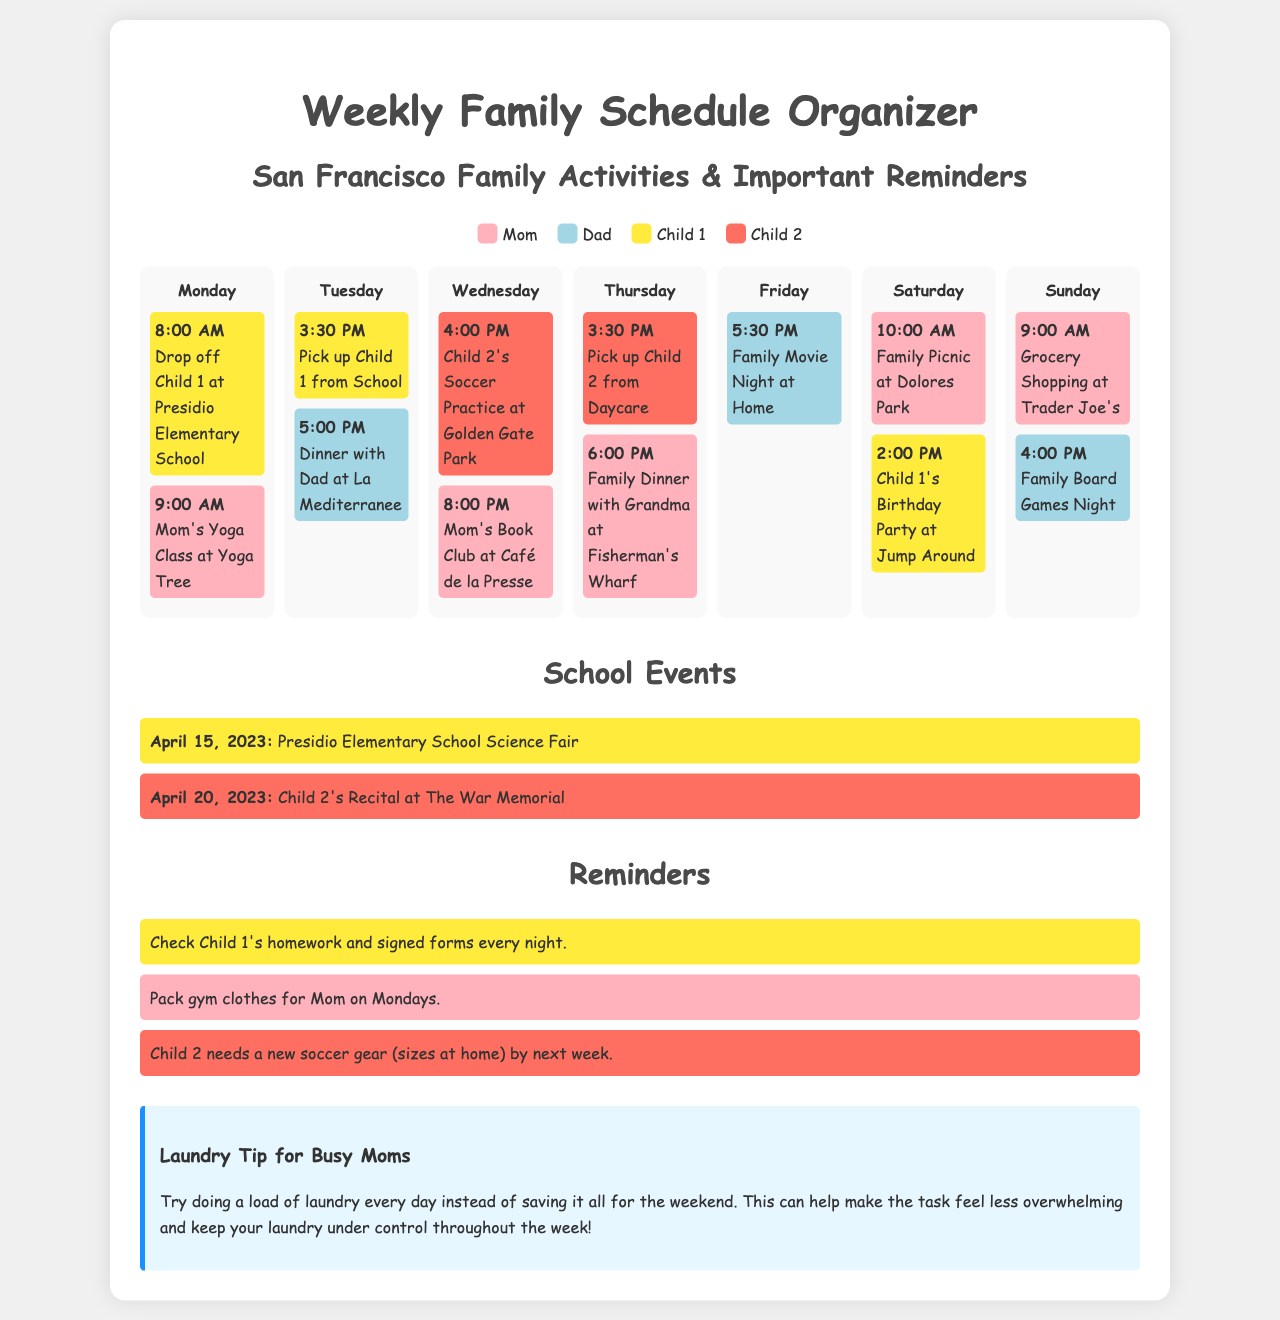What color represents Mom? The document includes a color legend that assigns a specific color to each family member, and Mom is represented by the color pink (#FFB1BC).
Answer: Pink What time does Child 1's birthday party start? The weekly schedule lists activities with their corresponding times, and Child 1's birthday party is scheduled for 2:00 PM on Saturday.
Answer: 2:00 PM On which day is Family Movie Night scheduled? The weekly schedule outlines various weekly activities, indicating that Family Movie Night is on Friday.
Answer: Friday What is the date of the science fair at Presidio Elementary School? The school events section specifies that the science fair is scheduled for April 15, 2023.
Answer: April 15, 2023 What is a reminder for Mom on Mondays? The reminders section includes specific tasks, revealing that Mom should pack gym clothes on Mondays.
Answer: Pack gym clothes How many activities are planned for Sunday? By referencing the weekly schedule, it shows there are two activities planned for Sunday.
Answer: Two What event does Child 2 have on April 20, 2023? The school events section notes that Child 2's recital is on this date.
Answer: Recital Which day features a family picnic? The weekly schedule indicates that the family picnic is planned for Saturday.
Answer: Saturday What is a laundry tip offered in the document? The document provides advice for busy moms suggesting to do a load of laundry every day.
Answer: Do a load of laundry every day 